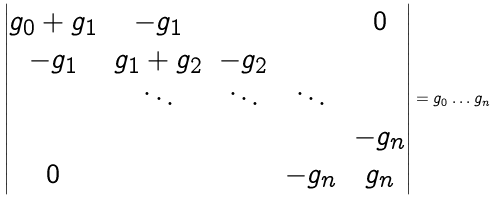Convert formula to latex. <formula><loc_0><loc_0><loc_500><loc_500>\begin{vmatrix} g _ { 0 } + g _ { 1 } & - g _ { 1 } & & & 0 \\ - g _ { 1 } & g _ { 1 } + g _ { 2 } & - g _ { 2 } & & \\ & \ddots & \ddots & \ddots & \\ & & & & - g _ { n } \\ 0 & & & - g _ { n } & g _ { n } \end{vmatrix} = g _ { 0 } \dots g _ { n }</formula> 